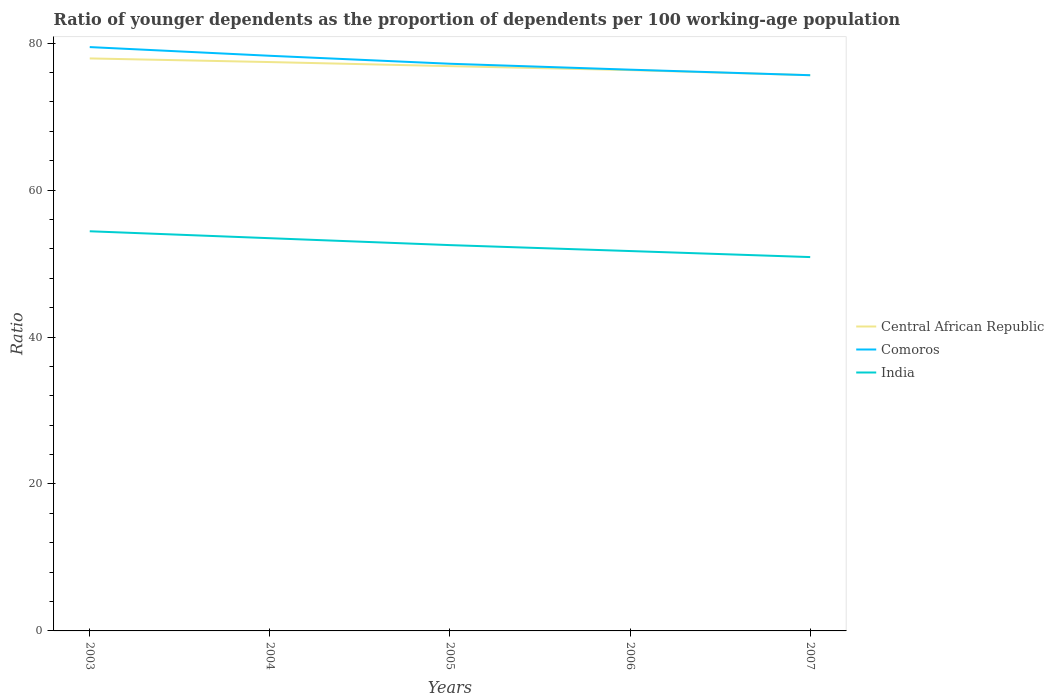Across all years, what is the maximum age dependency ratio(young) in Comoros?
Make the answer very short. 75.63. What is the total age dependency ratio(young) in India in the graph?
Offer a terse response. 0.94. What is the difference between the highest and the second highest age dependency ratio(young) in Comoros?
Your answer should be very brief. 3.83. What is the difference between the highest and the lowest age dependency ratio(young) in India?
Provide a short and direct response. 2. Is the age dependency ratio(young) in Central African Republic strictly greater than the age dependency ratio(young) in India over the years?
Your answer should be compact. No. Are the values on the major ticks of Y-axis written in scientific E-notation?
Keep it short and to the point. No. Does the graph contain grids?
Make the answer very short. No. How many legend labels are there?
Offer a very short reply. 3. How are the legend labels stacked?
Make the answer very short. Vertical. What is the title of the graph?
Ensure brevity in your answer.  Ratio of younger dependents as the proportion of dependents per 100 working-age population. Does "Bhutan" appear as one of the legend labels in the graph?
Your response must be concise. No. What is the label or title of the Y-axis?
Give a very brief answer. Ratio. What is the Ratio in Central African Republic in 2003?
Provide a short and direct response. 77.92. What is the Ratio in Comoros in 2003?
Provide a succinct answer. 79.46. What is the Ratio of India in 2003?
Provide a succinct answer. 54.39. What is the Ratio of Central African Republic in 2004?
Provide a succinct answer. 77.42. What is the Ratio in Comoros in 2004?
Make the answer very short. 78.28. What is the Ratio of India in 2004?
Your answer should be compact. 53.45. What is the Ratio in Central African Republic in 2005?
Your response must be concise. 76.87. What is the Ratio of Comoros in 2005?
Provide a succinct answer. 77.19. What is the Ratio in India in 2005?
Offer a very short reply. 52.51. What is the Ratio in Central African Republic in 2006?
Provide a succinct answer. 76.33. What is the Ratio in Comoros in 2006?
Keep it short and to the point. 76.39. What is the Ratio of India in 2006?
Give a very brief answer. 51.7. What is the Ratio in Central African Republic in 2007?
Your response must be concise. 75.64. What is the Ratio in Comoros in 2007?
Provide a short and direct response. 75.63. What is the Ratio in India in 2007?
Ensure brevity in your answer.  50.88. Across all years, what is the maximum Ratio of Central African Republic?
Give a very brief answer. 77.92. Across all years, what is the maximum Ratio in Comoros?
Offer a very short reply. 79.46. Across all years, what is the maximum Ratio of India?
Ensure brevity in your answer.  54.39. Across all years, what is the minimum Ratio of Central African Republic?
Give a very brief answer. 75.64. Across all years, what is the minimum Ratio in Comoros?
Your response must be concise. 75.63. Across all years, what is the minimum Ratio of India?
Your response must be concise. 50.88. What is the total Ratio in Central African Republic in the graph?
Ensure brevity in your answer.  384.17. What is the total Ratio of Comoros in the graph?
Offer a terse response. 386.95. What is the total Ratio in India in the graph?
Provide a short and direct response. 262.94. What is the difference between the Ratio in Central African Republic in 2003 and that in 2004?
Your answer should be very brief. 0.5. What is the difference between the Ratio of Comoros in 2003 and that in 2004?
Offer a very short reply. 1.18. What is the difference between the Ratio of India in 2003 and that in 2004?
Offer a terse response. 0.94. What is the difference between the Ratio of Comoros in 2003 and that in 2005?
Give a very brief answer. 2.27. What is the difference between the Ratio of India in 2003 and that in 2005?
Make the answer very short. 1.89. What is the difference between the Ratio in Central African Republic in 2003 and that in 2006?
Provide a succinct answer. 1.59. What is the difference between the Ratio in Comoros in 2003 and that in 2006?
Offer a very short reply. 3.07. What is the difference between the Ratio of India in 2003 and that in 2006?
Offer a terse response. 2.69. What is the difference between the Ratio of Central African Republic in 2003 and that in 2007?
Your answer should be compact. 2.28. What is the difference between the Ratio of Comoros in 2003 and that in 2007?
Provide a short and direct response. 3.83. What is the difference between the Ratio in India in 2003 and that in 2007?
Provide a succinct answer. 3.51. What is the difference between the Ratio of Central African Republic in 2004 and that in 2005?
Make the answer very short. 0.55. What is the difference between the Ratio of Comoros in 2004 and that in 2005?
Give a very brief answer. 1.08. What is the difference between the Ratio in India in 2004 and that in 2005?
Ensure brevity in your answer.  0.94. What is the difference between the Ratio in Central African Republic in 2004 and that in 2006?
Your answer should be compact. 1.1. What is the difference between the Ratio of Comoros in 2004 and that in 2006?
Ensure brevity in your answer.  1.89. What is the difference between the Ratio of India in 2004 and that in 2006?
Make the answer very short. 1.75. What is the difference between the Ratio in Central African Republic in 2004 and that in 2007?
Make the answer very short. 1.79. What is the difference between the Ratio in Comoros in 2004 and that in 2007?
Provide a short and direct response. 2.64. What is the difference between the Ratio in India in 2004 and that in 2007?
Keep it short and to the point. 2.57. What is the difference between the Ratio of Central African Republic in 2005 and that in 2006?
Make the answer very short. 0.54. What is the difference between the Ratio in Comoros in 2005 and that in 2006?
Make the answer very short. 0.81. What is the difference between the Ratio of India in 2005 and that in 2006?
Provide a succinct answer. 0.81. What is the difference between the Ratio of Central African Republic in 2005 and that in 2007?
Offer a terse response. 1.23. What is the difference between the Ratio of Comoros in 2005 and that in 2007?
Offer a very short reply. 1.56. What is the difference between the Ratio of India in 2005 and that in 2007?
Offer a very short reply. 1.63. What is the difference between the Ratio of Central African Republic in 2006 and that in 2007?
Your answer should be compact. 0.69. What is the difference between the Ratio of Comoros in 2006 and that in 2007?
Provide a succinct answer. 0.75. What is the difference between the Ratio of India in 2006 and that in 2007?
Your answer should be compact. 0.82. What is the difference between the Ratio of Central African Republic in 2003 and the Ratio of Comoros in 2004?
Keep it short and to the point. -0.36. What is the difference between the Ratio in Central African Republic in 2003 and the Ratio in India in 2004?
Provide a succinct answer. 24.47. What is the difference between the Ratio in Comoros in 2003 and the Ratio in India in 2004?
Offer a very short reply. 26.01. What is the difference between the Ratio in Central African Republic in 2003 and the Ratio in Comoros in 2005?
Make the answer very short. 0.72. What is the difference between the Ratio of Central African Republic in 2003 and the Ratio of India in 2005?
Offer a terse response. 25.41. What is the difference between the Ratio in Comoros in 2003 and the Ratio in India in 2005?
Give a very brief answer. 26.95. What is the difference between the Ratio in Central African Republic in 2003 and the Ratio in Comoros in 2006?
Your response must be concise. 1.53. What is the difference between the Ratio in Central African Republic in 2003 and the Ratio in India in 2006?
Make the answer very short. 26.22. What is the difference between the Ratio in Comoros in 2003 and the Ratio in India in 2006?
Keep it short and to the point. 27.76. What is the difference between the Ratio in Central African Republic in 2003 and the Ratio in Comoros in 2007?
Make the answer very short. 2.29. What is the difference between the Ratio in Central African Republic in 2003 and the Ratio in India in 2007?
Ensure brevity in your answer.  27.04. What is the difference between the Ratio of Comoros in 2003 and the Ratio of India in 2007?
Keep it short and to the point. 28.58. What is the difference between the Ratio of Central African Republic in 2004 and the Ratio of Comoros in 2005?
Offer a terse response. 0.23. What is the difference between the Ratio in Central African Republic in 2004 and the Ratio in India in 2005?
Provide a succinct answer. 24.91. What is the difference between the Ratio of Comoros in 2004 and the Ratio of India in 2005?
Provide a succinct answer. 25.77. What is the difference between the Ratio of Central African Republic in 2004 and the Ratio of Comoros in 2006?
Offer a very short reply. 1.04. What is the difference between the Ratio in Central African Republic in 2004 and the Ratio in India in 2006?
Your response must be concise. 25.72. What is the difference between the Ratio in Comoros in 2004 and the Ratio in India in 2006?
Make the answer very short. 26.58. What is the difference between the Ratio of Central African Republic in 2004 and the Ratio of Comoros in 2007?
Your response must be concise. 1.79. What is the difference between the Ratio of Central African Republic in 2004 and the Ratio of India in 2007?
Offer a very short reply. 26.54. What is the difference between the Ratio of Comoros in 2004 and the Ratio of India in 2007?
Make the answer very short. 27.4. What is the difference between the Ratio in Central African Republic in 2005 and the Ratio in Comoros in 2006?
Your answer should be very brief. 0.48. What is the difference between the Ratio of Central African Republic in 2005 and the Ratio of India in 2006?
Provide a short and direct response. 25.17. What is the difference between the Ratio in Comoros in 2005 and the Ratio in India in 2006?
Provide a succinct answer. 25.49. What is the difference between the Ratio in Central African Republic in 2005 and the Ratio in Comoros in 2007?
Ensure brevity in your answer.  1.24. What is the difference between the Ratio in Central African Republic in 2005 and the Ratio in India in 2007?
Offer a very short reply. 25.99. What is the difference between the Ratio in Comoros in 2005 and the Ratio in India in 2007?
Your answer should be very brief. 26.31. What is the difference between the Ratio of Central African Republic in 2006 and the Ratio of Comoros in 2007?
Keep it short and to the point. 0.69. What is the difference between the Ratio in Central African Republic in 2006 and the Ratio in India in 2007?
Provide a short and direct response. 25.45. What is the difference between the Ratio of Comoros in 2006 and the Ratio of India in 2007?
Your answer should be compact. 25.51. What is the average Ratio in Central African Republic per year?
Give a very brief answer. 76.83. What is the average Ratio of Comoros per year?
Give a very brief answer. 77.39. What is the average Ratio in India per year?
Make the answer very short. 52.59. In the year 2003, what is the difference between the Ratio of Central African Republic and Ratio of Comoros?
Your answer should be compact. -1.54. In the year 2003, what is the difference between the Ratio of Central African Republic and Ratio of India?
Your answer should be very brief. 23.52. In the year 2003, what is the difference between the Ratio in Comoros and Ratio in India?
Give a very brief answer. 25.07. In the year 2004, what is the difference between the Ratio in Central African Republic and Ratio in Comoros?
Your answer should be very brief. -0.85. In the year 2004, what is the difference between the Ratio of Central African Republic and Ratio of India?
Provide a succinct answer. 23.97. In the year 2004, what is the difference between the Ratio in Comoros and Ratio in India?
Provide a short and direct response. 24.83. In the year 2005, what is the difference between the Ratio of Central African Republic and Ratio of Comoros?
Keep it short and to the point. -0.33. In the year 2005, what is the difference between the Ratio of Central African Republic and Ratio of India?
Give a very brief answer. 24.36. In the year 2005, what is the difference between the Ratio of Comoros and Ratio of India?
Your answer should be very brief. 24.68. In the year 2006, what is the difference between the Ratio in Central African Republic and Ratio in Comoros?
Your response must be concise. -0.06. In the year 2006, what is the difference between the Ratio in Central African Republic and Ratio in India?
Ensure brevity in your answer.  24.62. In the year 2006, what is the difference between the Ratio in Comoros and Ratio in India?
Ensure brevity in your answer.  24.69. In the year 2007, what is the difference between the Ratio in Central African Republic and Ratio in Comoros?
Keep it short and to the point. 0. In the year 2007, what is the difference between the Ratio of Central African Republic and Ratio of India?
Your response must be concise. 24.76. In the year 2007, what is the difference between the Ratio in Comoros and Ratio in India?
Make the answer very short. 24.75. What is the ratio of the Ratio in Central African Republic in 2003 to that in 2004?
Make the answer very short. 1.01. What is the ratio of the Ratio in Comoros in 2003 to that in 2004?
Make the answer very short. 1.02. What is the ratio of the Ratio of India in 2003 to that in 2004?
Make the answer very short. 1.02. What is the ratio of the Ratio in Central African Republic in 2003 to that in 2005?
Make the answer very short. 1.01. What is the ratio of the Ratio in Comoros in 2003 to that in 2005?
Your response must be concise. 1.03. What is the ratio of the Ratio in India in 2003 to that in 2005?
Provide a succinct answer. 1.04. What is the ratio of the Ratio of Central African Republic in 2003 to that in 2006?
Your answer should be compact. 1.02. What is the ratio of the Ratio in Comoros in 2003 to that in 2006?
Your response must be concise. 1.04. What is the ratio of the Ratio in India in 2003 to that in 2006?
Your answer should be very brief. 1.05. What is the ratio of the Ratio of Central African Republic in 2003 to that in 2007?
Ensure brevity in your answer.  1.03. What is the ratio of the Ratio of Comoros in 2003 to that in 2007?
Your answer should be compact. 1.05. What is the ratio of the Ratio of India in 2003 to that in 2007?
Give a very brief answer. 1.07. What is the ratio of the Ratio in Central African Republic in 2004 to that in 2005?
Keep it short and to the point. 1.01. What is the ratio of the Ratio of India in 2004 to that in 2005?
Provide a short and direct response. 1.02. What is the ratio of the Ratio in Central African Republic in 2004 to that in 2006?
Your answer should be very brief. 1.01. What is the ratio of the Ratio of Comoros in 2004 to that in 2006?
Your answer should be very brief. 1.02. What is the ratio of the Ratio in India in 2004 to that in 2006?
Ensure brevity in your answer.  1.03. What is the ratio of the Ratio of Central African Republic in 2004 to that in 2007?
Your answer should be compact. 1.02. What is the ratio of the Ratio in Comoros in 2004 to that in 2007?
Keep it short and to the point. 1.03. What is the ratio of the Ratio of India in 2004 to that in 2007?
Provide a succinct answer. 1.05. What is the ratio of the Ratio in Central African Republic in 2005 to that in 2006?
Your answer should be very brief. 1.01. What is the ratio of the Ratio of Comoros in 2005 to that in 2006?
Your answer should be very brief. 1.01. What is the ratio of the Ratio in India in 2005 to that in 2006?
Offer a very short reply. 1.02. What is the ratio of the Ratio of Central African Republic in 2005 to that in 2007?
Offer a terse response. 1.02. What is the ratio of the Ratio in Comoros in 2005 to that in 2007?
Give a very brief answer. 1.02. What is the ratio of the Ratio of India in 2005 to that in 2007?
Provide a succinct answer. 1.03. What is the ratio of the Ratio in Central African Republic in 2006 to that in 2007?
Your answer should be compact. 1.01. What is the ratio of the Ratio of Comoros in 2006 to that in 2007?
Provide a succinct answer. 1.01. What is the ratio of the Ratio in India in 2006 to that in 2007?
Offer a terse response. 1.02. What is the difference between the highest and the second highest Ratio in Central African Republic?
Offer a terse response. 0.5. What is the difference between the highest and the second highest Ratio of Comoros?
Provide a succinct answer. 1.18. What is the difference between the highest and the second highest Ratio of India?
Your answer should be very brief. 0.94. What is the difference between the highest and the lowest Ratio of Central African Republic?
Provide a short and direct response. 2.28. What is the difference between the highest and the lowest Ratio in Comoros?
Offer a terse response. 3.83. What is the difference between the highest and the lowest Ratio in India?
Make the answer very short. 3.51. 